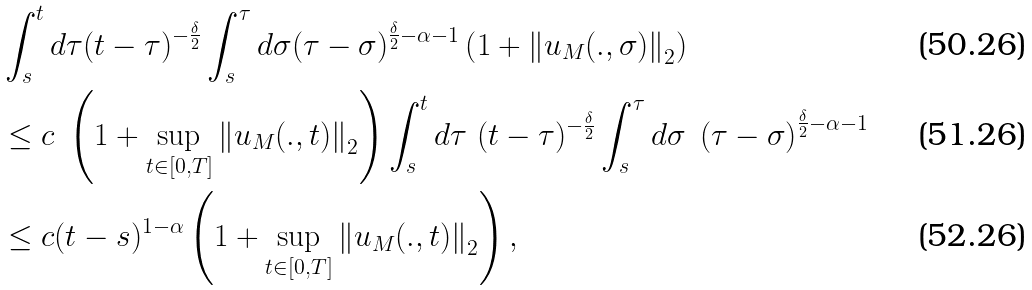<formula> <loc_0><loc_0><loc_500><loc_500>& \int _ { s } ^ { t } d \tau ( t - \tau ) ^ { - \frac { \delta } { 2 } } \int _ { s } ^ { \tau } d \sigma ( \tau - \sigma ) ^ { \frac { \delta } { 2 } - \alpha - 1 } \left ( 1 + \left \| u _ { M } ( . , \sigma ) \right \| _ { 2 } \right ) \\ & \leq c \ \left ( 1 + \sup _ { t \in [ 0 , T ] } \left \| u _ { M } ( . , t ) \right \| _ { 2 } \right ) \int _ { s } ^ { t } d \tau \ ( t - \tau ) ^ { - \frac { \delta } { 2 } } \int _ { s } ^ { \tau } d \sigma \ \left ( \tau - \sigma \right ) ^ { \frac { \delta } { 2 } - \alpha - 1 } \\ & \leq c ( t - s ) ^ { 1 - \alpha } \left ( 1 + \sup _ { t \in [ 0 , T ] } \left \| u _ { M } ( . , t ) \right \| _ { 2 } \right ) ,</formula> 